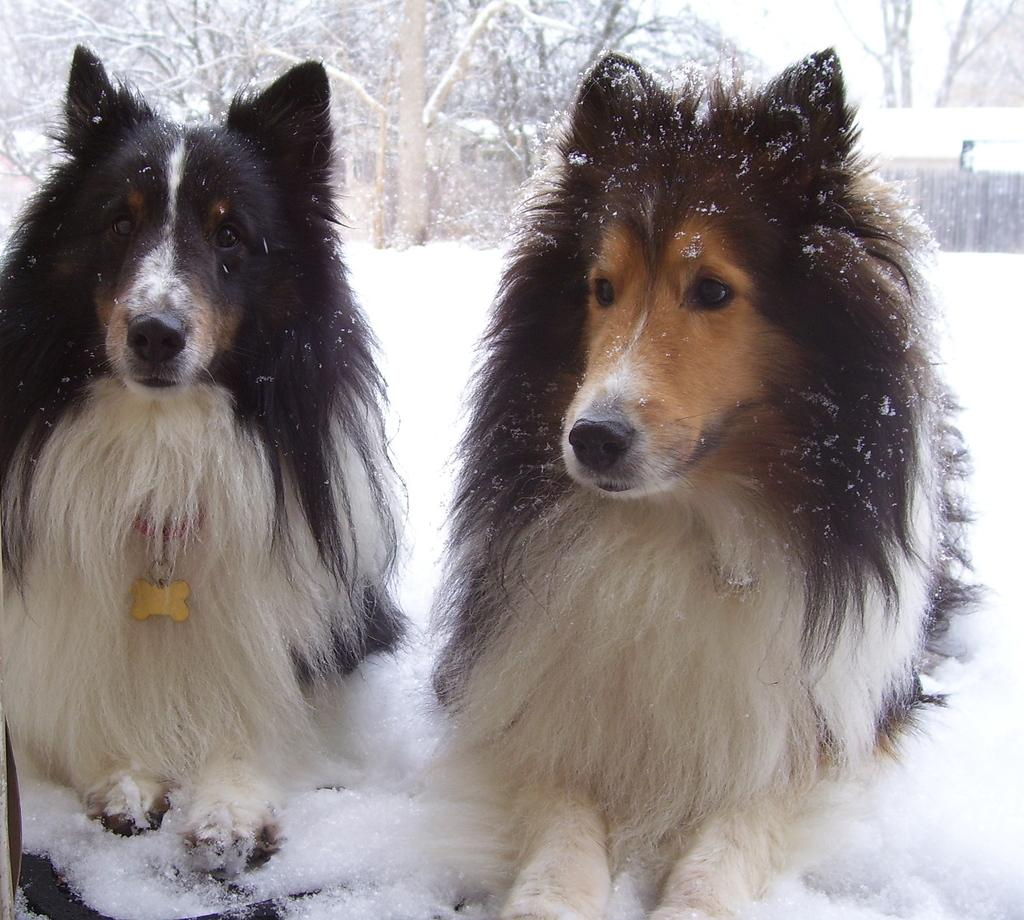How many dogs are present in the image? There are two dogs in the image. What type of natural elements can be seen in the image? There are many trees in the image. What type of structure is visible in the image? There is a house in the image. What is the weather like in the image? There is snow in the image, indicating a cold and likely wintery environment. What type of steam can be seen coming from the roof of the house in the image? There is no steam visible in the image, nor is there a roof of a house present. 